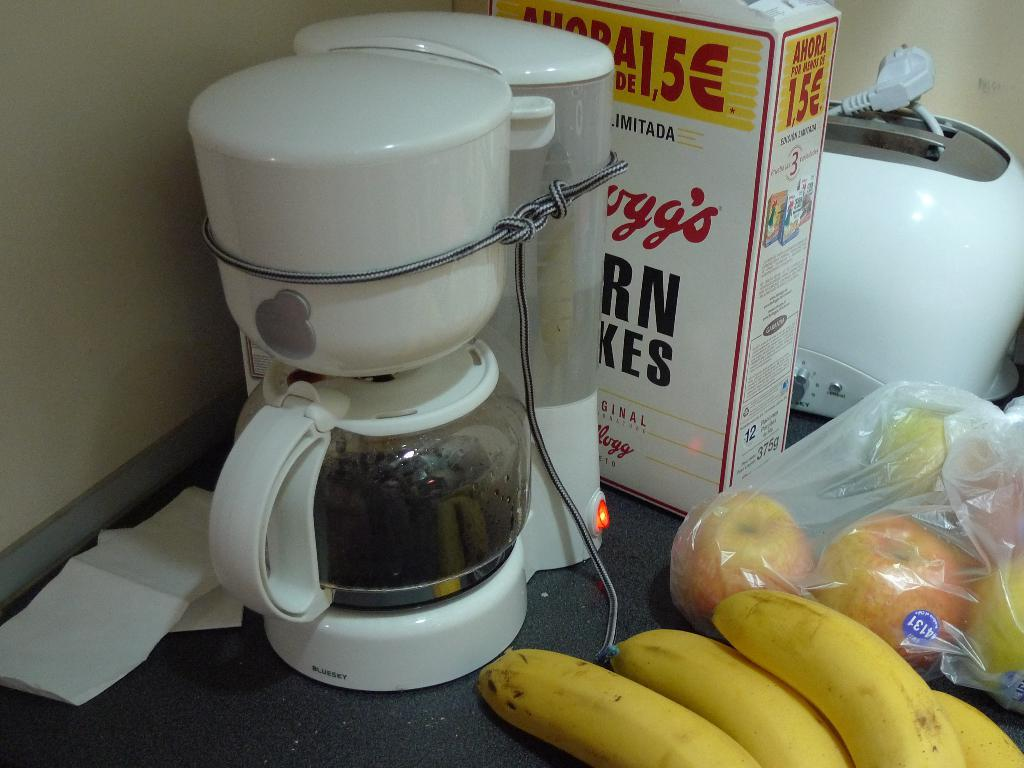What appliance is present in the image? There is a juicer in the image. What type of fruit is visible in the image? There are bananas in the image. What other types of fruits can be seen in the image? There are fruits in the image. What is the box used for in the image? The purpose of the box in the image is not clear, but it is present. What other objects are on a surface in the image? There are other objects on a surface in the image, but their specific identities are not mentioned in the facts. What type of rice is being cooked in the image? There is no rice present in the image. How many pizzas are visible in the image? There are no pizzas present in the image. What is the pail used for in the image? There is no pail present in the image. 